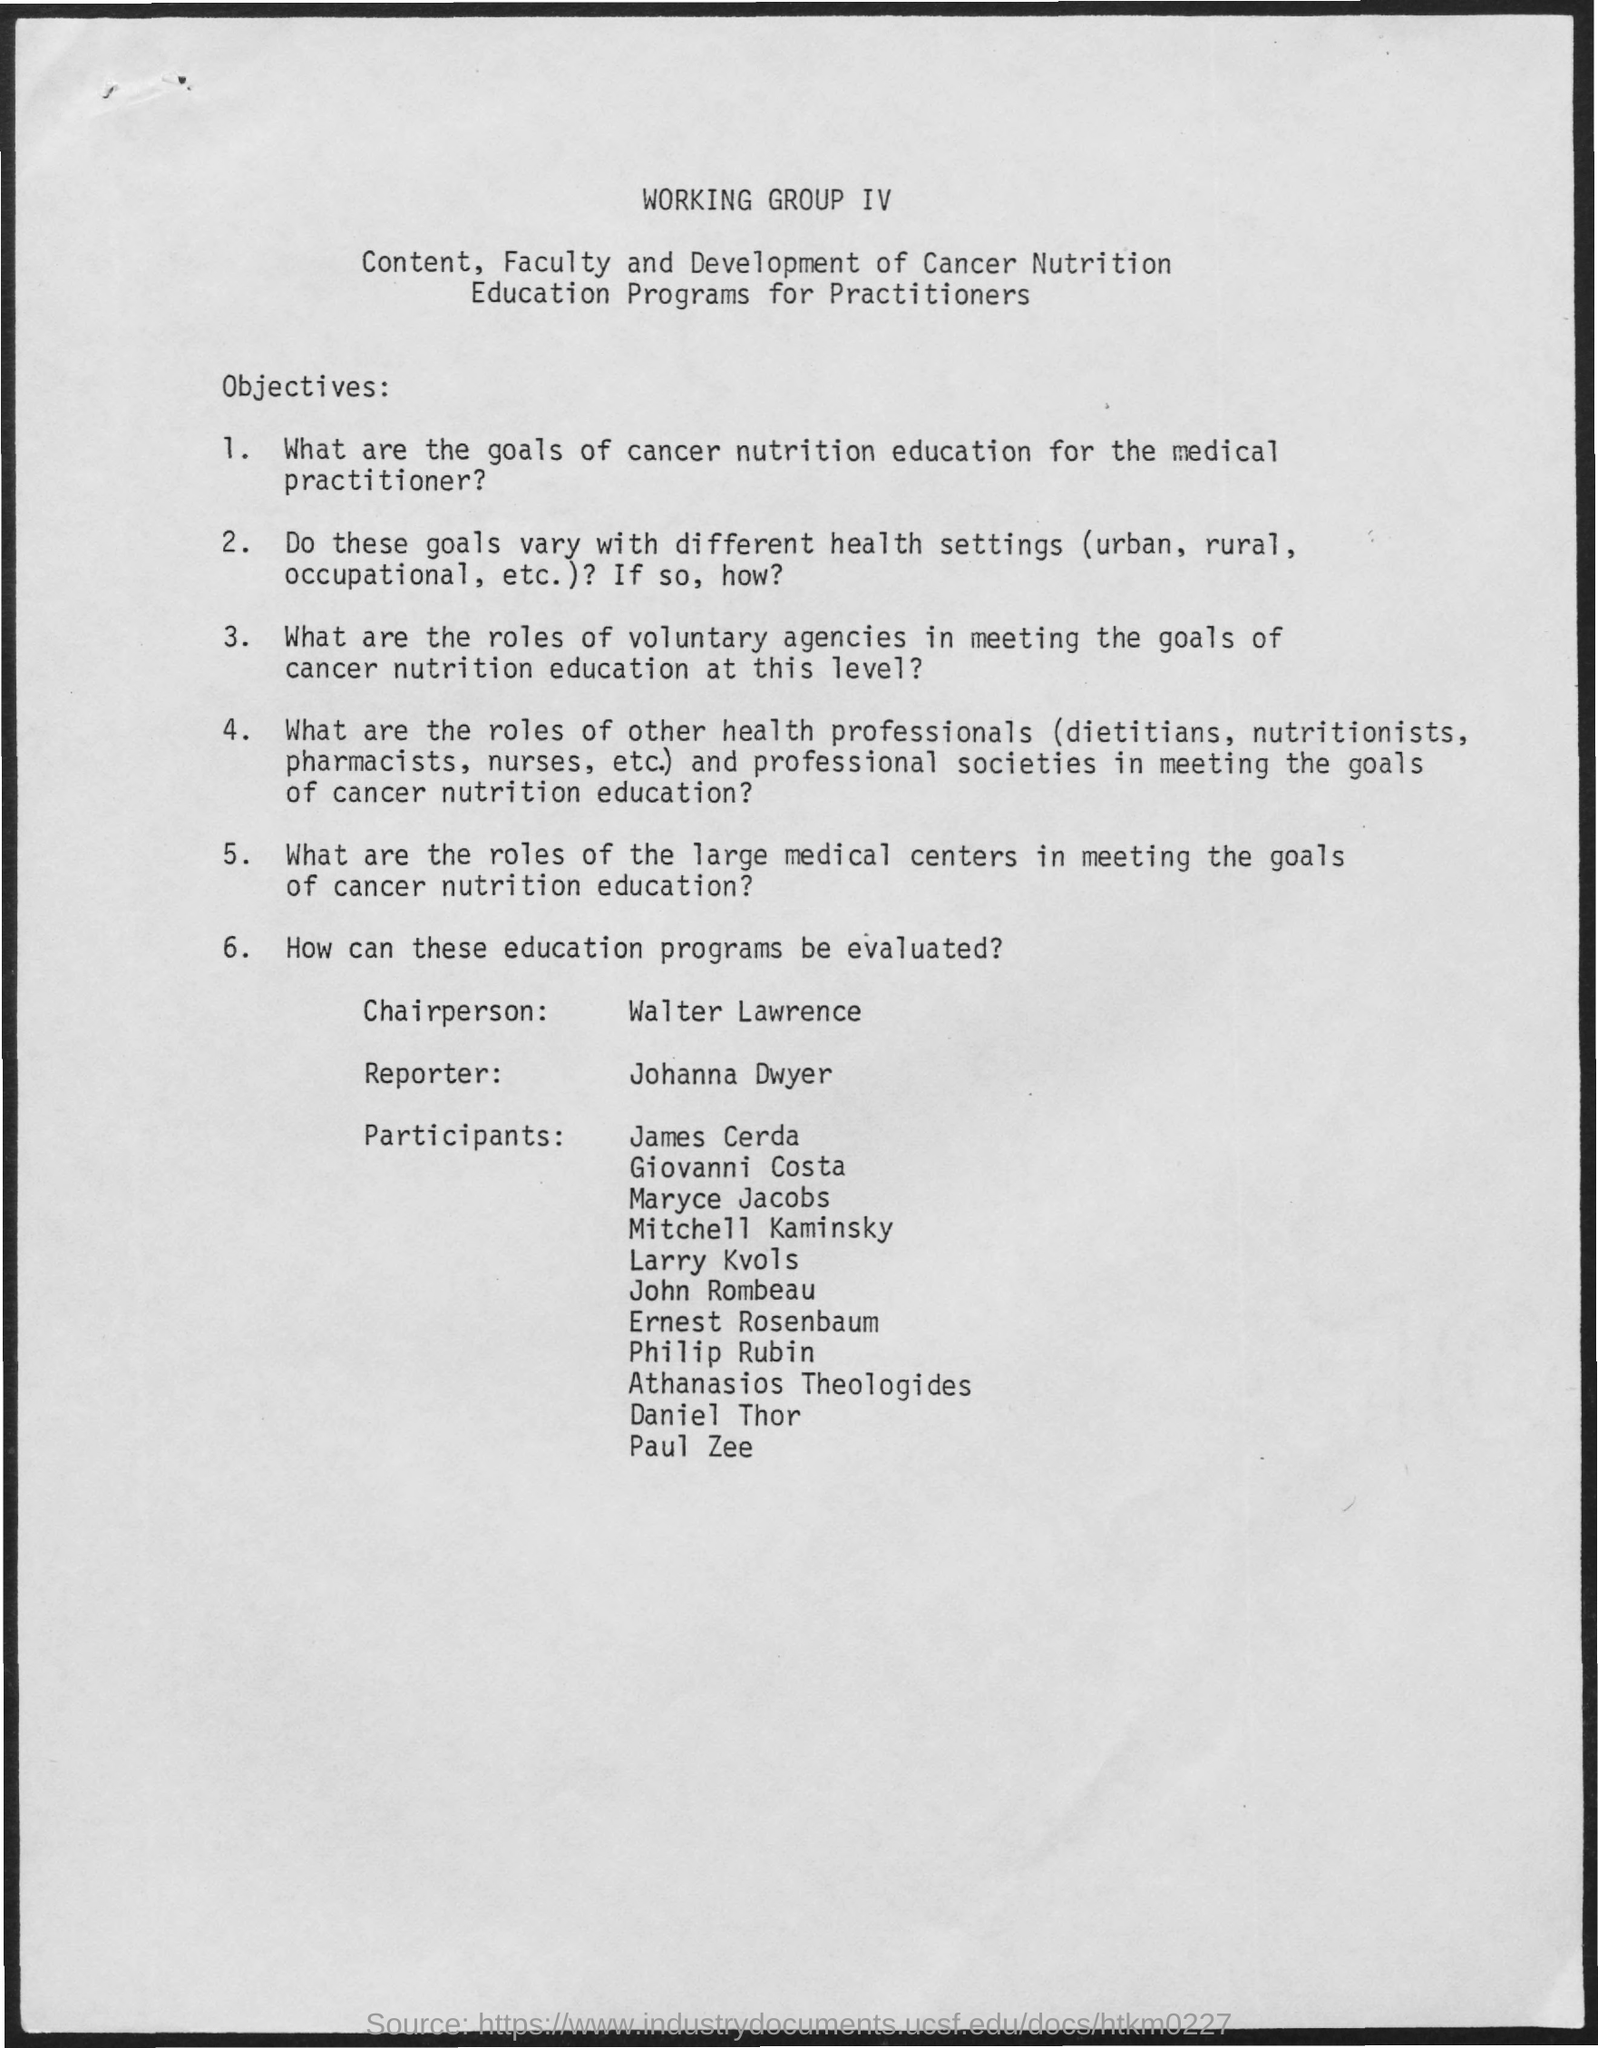what is the name of the chairperson mentioned in the given page ?
 walter lawrence 